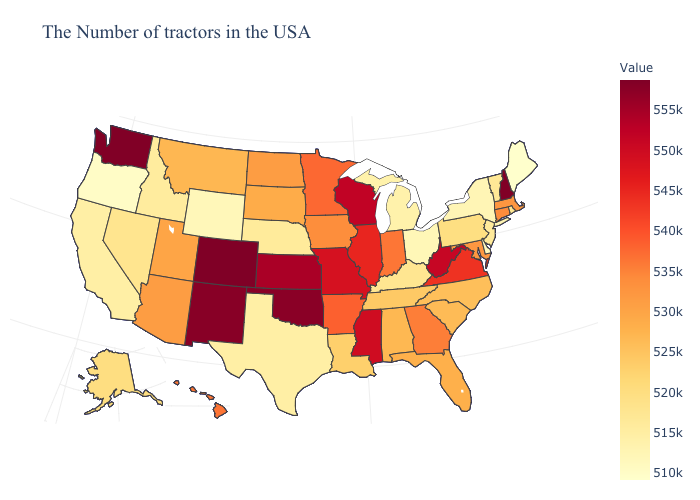Among the states that border Vermont , does New York have the lowest value?
Give a very brief answer. Yes. Does New Hampshire have the highest value in the USA?
Concise answer only. No. Which states hav the highest value in the Northeast?
Write a very short answer. New Hampshire. 